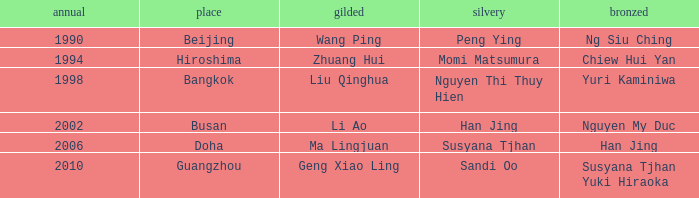What Gold has the Year of 2006? Ma Lingjuan. 